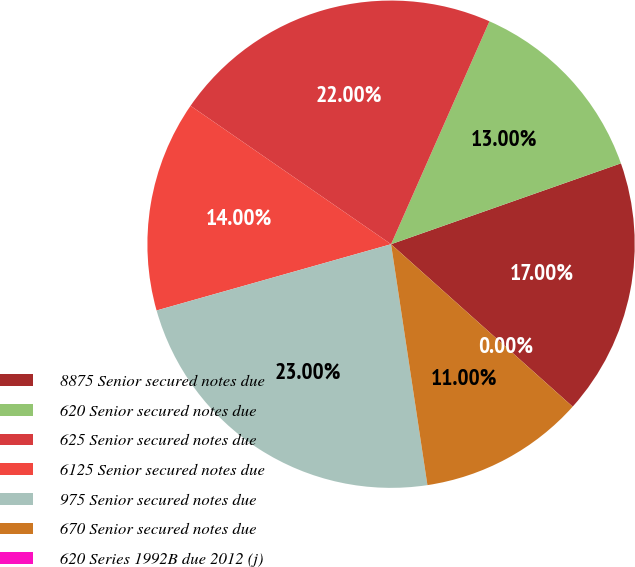Convert chart to OTSL. <chart><loc_0><loc_0><loc_500><loc_500><pie_chart><fcel>8875 Senior secured notes due<fcel>620 Senior secured notes due<fcel>625 Senior secured notes due<fcel>6125 Senior secured notes due<fcel>975 Senior secured notes due<fcel>670 Senior secured notes due<fcel>620 Series 1992B due 2012 (j)<nl><fcel>17.0%<fcel>13.0%<fcel>22.0%<fcel>14.0%<fcel>23.0%<fcel>11.0%<fcel>0.0%<nl></chart> 